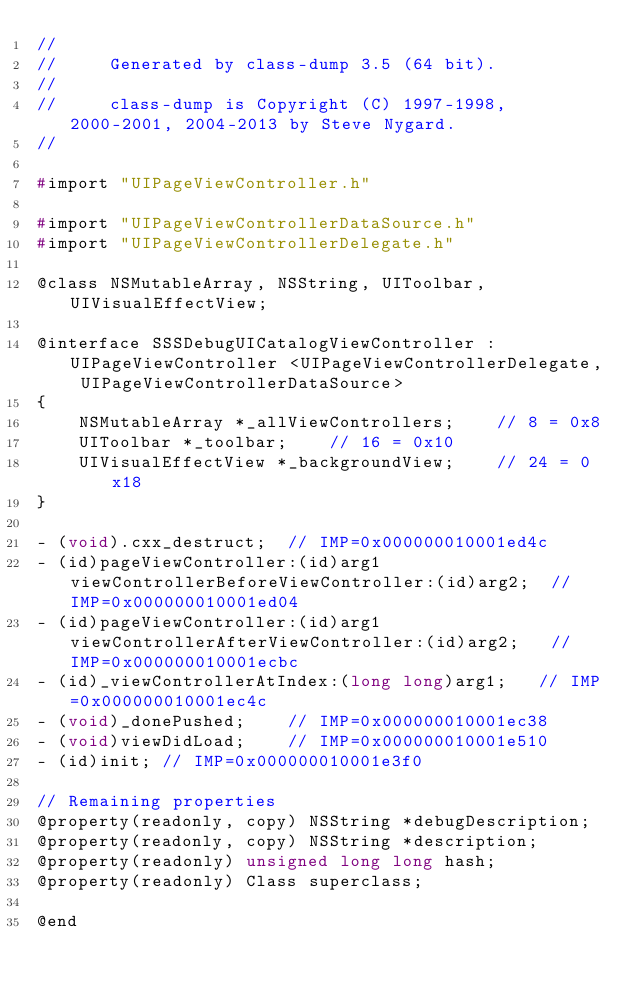<code> <loc_0><loc_0><loc_500><loc_500><_C_>//
//     Generated by class-dump 3.5 (64 bit).
//
//     class-dump is Copyright (C) 1997-1998, 2000-2001, 2004-2013 by Steve Nygard.
//

#import "UIPageViewController.h"

#import "UIPageViewControllerDataSource.h"
#import "UIPageViewControllerDelegate.h"

@class NSMutableArray, NSString, UIToolbar, UIVisualEffectView;

@interface SSSDebugUICatalogViewController : UIPageViewController <UIPageViewControllerDelegate, UIPageViewControllerDataSource>
{
    NSMutableArray *_allViewControllers;	// 8 = 0x8
    UIToolbar *_toolbar;	// 16 = 0x10
    UIVisualEffectView *_backgroundView;	// 24 = 0x18
}

- (void).cxx_destruct;	// IMP=0x000000010001ed4c
- (id)pageViewController:(id)arg1 viewControllerBeforeViewController:(id)arg2;	// IMP=0x000000010001ed04
- (id)pageViewController:(id)arg1 viewControllerAfterViewController:(id)arg2;	// IMP=0x000000010001ecbc
- (id)_viewControllerAtIndex:(long long)arg1;	// IMP=0x000000010001ec4c
- (void)_donePushed;	// IMP=0x000000010001ec38
- (void)viewDidLoad;	// IMP=0x000000010001e510
- (id)init;	// IMP=0x000000010001e3f0

// Remaining properties
@property(readonly, copy) NSString *debugDescription;
@property(readonly, copy) NSString *description;
@property(readonly) unsigned long long hash;
@property(readonly) Class superclass;

@end

</code> 